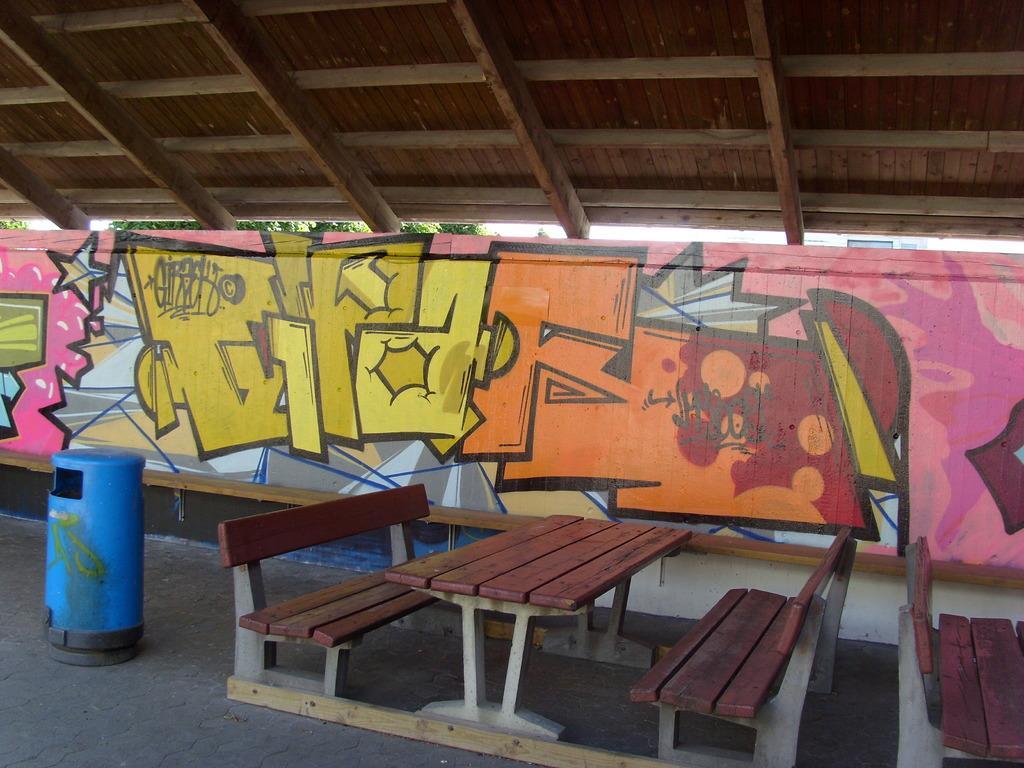In one or two sentences, can you explain what this image depicts? in the center we can see bench and table. On the left side we can see the dustbin. Coming to the background we can see shutter. 